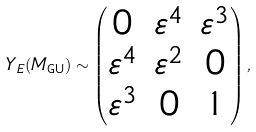Convert formula to latex. <formula><loc_0><loc_0><loc_500><loc_500>Y _ { E } ( M _ { \text {GU} } ) \sim \begin{pmatrix} 0 & \varepsilon ^ { 4 } & \varepsilon ^ { 3 } \\ \varepsilon ^ { 4 } & \varepsilon ^ { 2 } & 0 \\ \varepsilon ^ { 3 } & 0 & 1 \end{pmatrix} ,</formula> 